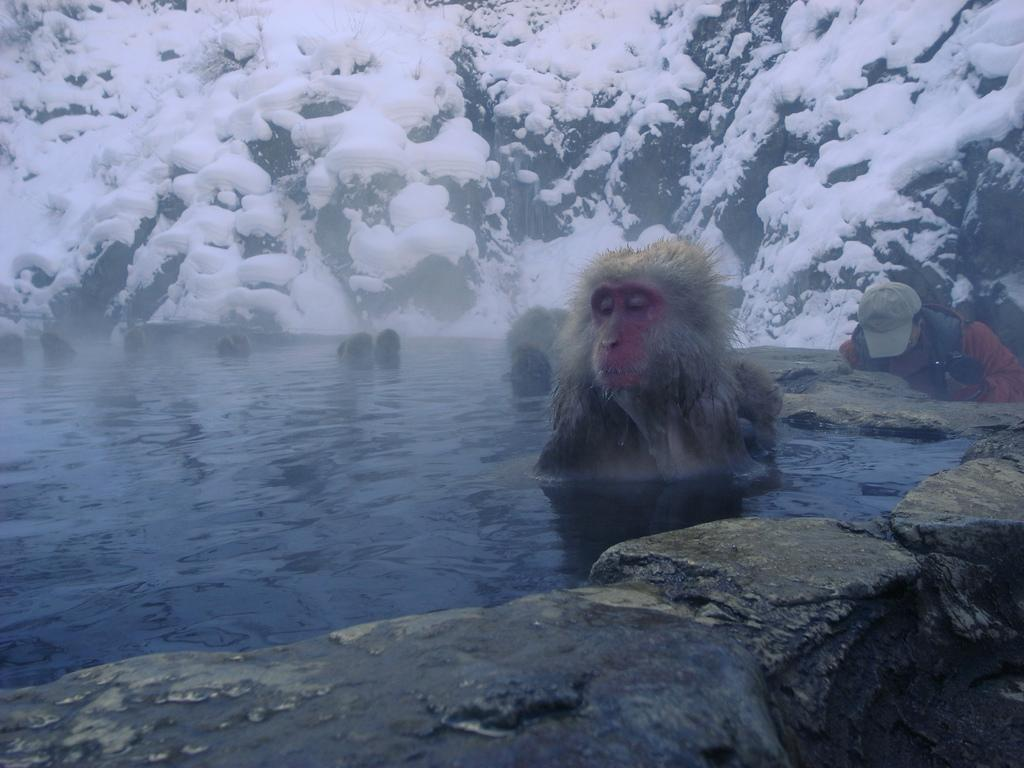What type of animal is in the image? There is a monkey in the image. Can you describe the person in the image? There is a person wearing a cap in the image. What is the terrain like in the image? There is water and rocks visible in the image. What can be seen in the background of the image? There is a snowy mountain in the background of the image. What type of copper branch can be seen in the image? There is no copper branch present in the image. How many hydrants are visible in the image? There are no hydrants present in the image. 